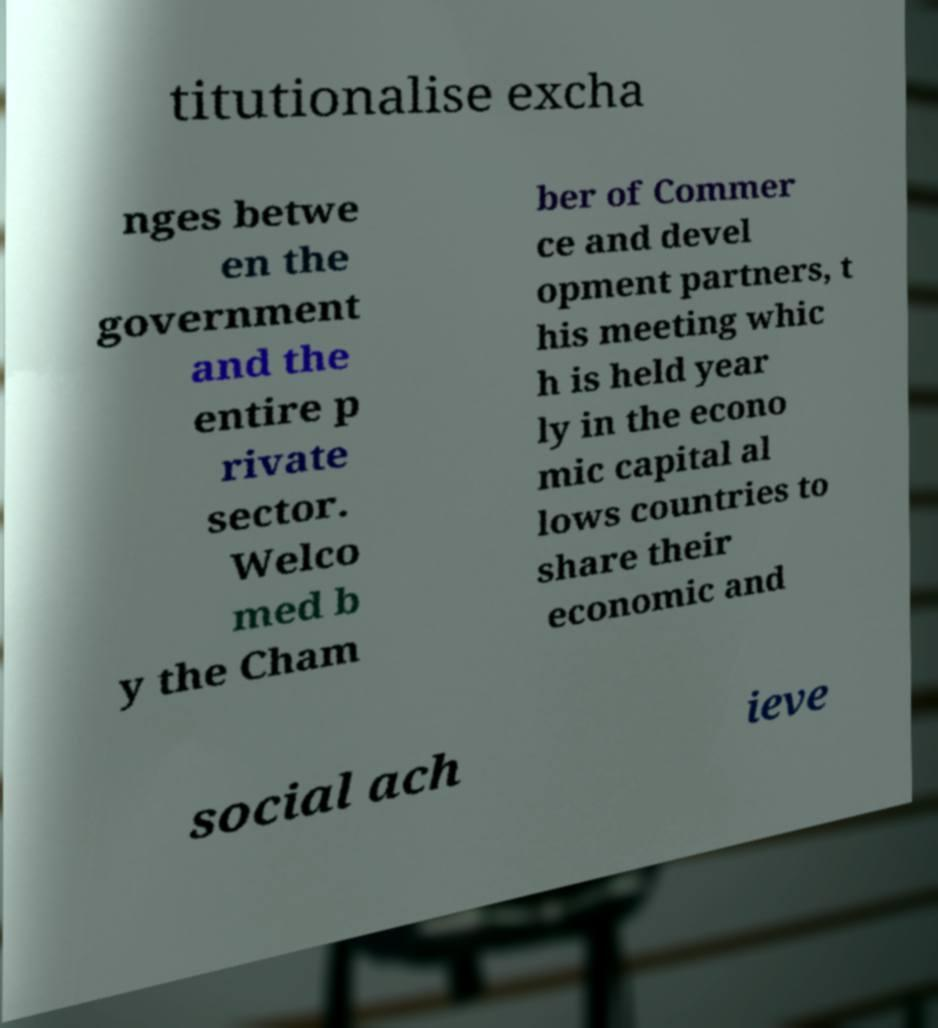Please identify and transcribe the text found in this image. titutionalise excha nges betwe en the government and the entire p rivate sector. Welco med b y the Cham ber of Commer ce and devel opment partners, t his meeting whic h is held year ly in the econo mic capital al lows countries to share their economic and social ach ieve 